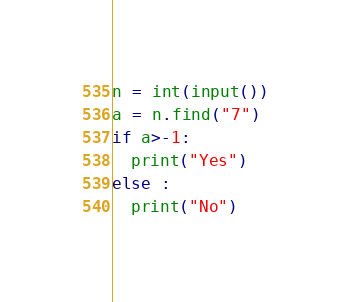<code> <loc_0><loc_0><loc_500><loc_500><_Python_>n = int(input())
a = n.find("7")
if a>-1:
  print("Yes")
else :
  print("No")</code> 